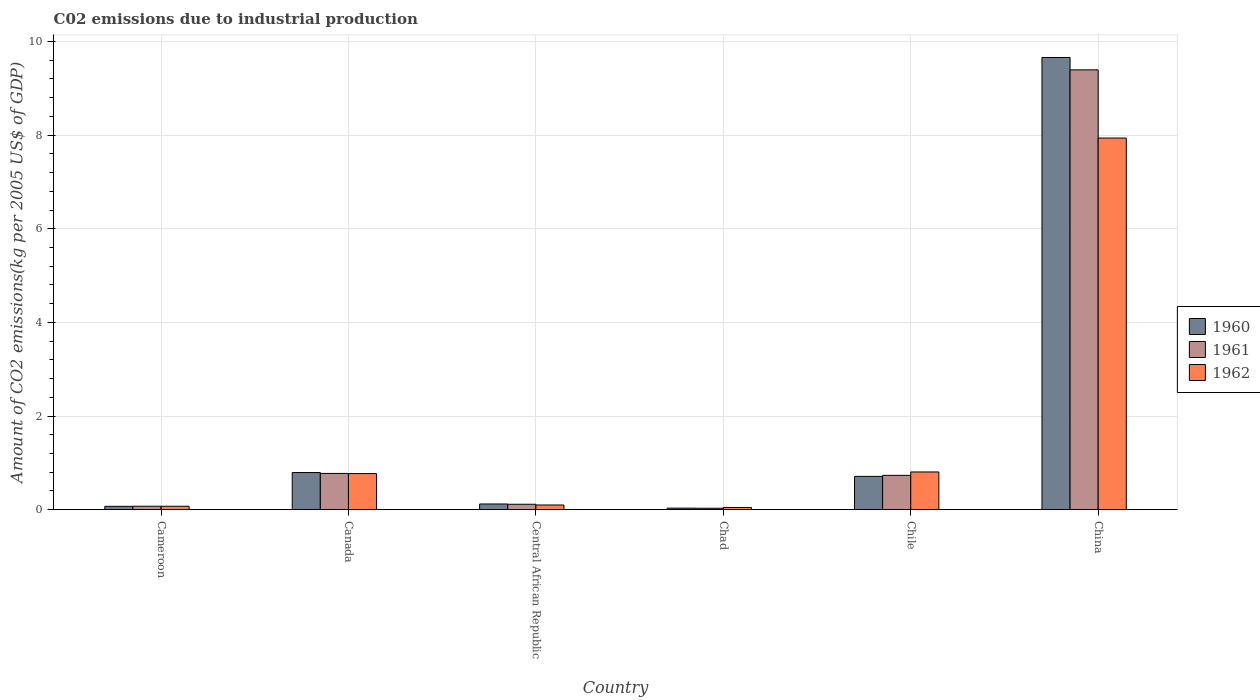How many bars are there on the 1st tick from the left?
Keep it short and to the point. 3. What is the label of the 4th group of bars from the left?
Give a very brief answer. Chad. In how many cases, is the number of bars for a given country not equal to the number of legend labels?
Ensure brevity in your answer.  0. What is the amount of CO2 emitted due to industrial production in 1960 in Canada?
Provide a short and direct response. 0.79. Across all countries, what is the maximum amount of CO2 emitted due to industrial production in 1962?
Make the answer very short. 7.94. Across all countries, what is the minimum amount of CO2 emitted due to industrial production in 1962?
Keep it short and to the point. 0.05. In which country was the amount of CO2 emitted due to industrial production in 1961 maximum?
Offer a terse response. China. In which country was the amount of CO2 emitted due to industrial production in 1961 minimum?
Offer a terse response. Chad. What is the total amount of CO2 emitted due to industrial production in 1961 in the graph?
Your answer should be compact. 11.12. What is the difference between the amount of CO2 emitted due to industrial production in 1960 in Central African Republic and that in Chad?
Ensure brevity in your answer.  0.09. What is the difference between the amount of CO2 emitted due to industrial production in 1960 in Canada and the amount of CO2 emitted due to industrial production in 1961 in Central African Republic?
Keep it short and to the point. 0.68. What is the average amount of CO2 emitted due to industrial production in 1962 per country?
Offer a very short reply. 1.62. What is the difference between the amount of CO2 emitted due to industrial production of/in 1960 and amount of CO2 emitted due to industrial production of/in 1961 in Cameroon?
Make the answer very short. -0. What is the ratio of the amount of CO2 emitted due to industrial production in 1961 in Canada to that in China?
Offer a very short reply. 0.08. What is the difference between the highest and the second highest amount of CO2 emitted due to industrial production in 1961?
Provide a succinct answer. -8.62. What is the difference between the highest and the lowest amount of CO2 emitted due to industrial production in 1960?
Provide a short and direct response. 9.62. In how many countries, is the amount of CO2 emitted due to industrial production in 1961 greater than the average amount of CO2 emitted due to industrial production in 1961 taken over all countries?
Give a very brief answer. 1. What does the 2nd bar from the left in Central African Republic represents?
Your answer should be very brief. 1961. What does the 2nd bar from the right in Cameroon represents?
Your answer should be compact. 1961. Are all the bars in the graph horizontal?
Give a very brief answer. No. How many countries are there in the graph?
Provide a succinct answer. 6. What is the difference between two consecutive major ticks on the Y-axis?
Ensure brevity in your answer.  2. Where does the legend appear in the graph?
Your response must be concise. Center right. What is the title of the graph?
Provide a short and direct response. C02 emissions due to industrial production. Does "1973" appear as one of the legend labels in the graph?
Offer a terse response. No. What is the label or title of the Y-axis?
Ensure brevity in your answer.  Amount of CO2 emissions(kg per 2005 US$ of GDP). What is the Amount of CO2 emissions(kg per 2005 US$ of GDP) of 1960 in Cameroon?
Offer a very short reply. 0.07. What is the Amount of CO2 emissions(kg per 2005 US$ of GDP) in 1961 in Cameroon?
Provide a short and direct response. 0.07. What is the Amount of CO2 emissions(kg per 2005 US$ of GDP) of 1962 in Cameroon?
Your answer should be very brief. 0.07. What is the Amount of CO2 emissions(kg per 2005 US$ of GDP) of 1960 in Canada?
Your response must be concise. 0.79. What is the Amount of CO2 emissions(kg per 2005 US$ of GDP) in 1961 in Canada?
Make the answer very short. 0.77. What is the Amount of CO2 emissions(kg per 2005 US$ of GDP) in 1962 in Canada?
Ensure brevity in your answer.  0.77. What is the Amount of CO2 emissions(kg per 2005 US$ of GDP) in 1960 in Central African Republic?
Make the answer very short. 0.12. What is the Amount of CO2 emissions(kg per 2005 US$ of GDP) in 1961 in Central African Republic?
Keep it short and to the point. 0.12. What is the Amount of CO2 emissions(kg per 2005 US$ of GDP) in 1962 in Central African Republic?
Provide a short and direct response. 0.1. What is the Amount of CO2 emissions(kg per 2005 US$ of GDP) in 1960 in Chad?
Offer a terse response. 0.03. What is the Amount of CO2 emissions(kg per 2005 US$ of GDP) of 1961 in Chad?
Make the answer very short. 0.03. What is the Amount of CO2 emissions(kg per 2005 US$ of GDP) of 1962 in Chad?
Give a very brief answer. 0.05. What is the Amount of CO2 emissions(kg per 2005 US$ of GDP) of 1960 in Chile?
Provide a succinct answer. 0.71. What is the Amount of CO2 emissions(kg per 2005 US$ of GDP) in 1961 in Chile?
Offer a very short reply. 0.73. What is the Amount of CO2 emissions(kg per 2005 US$ of GDP) in 1962 in Chile?
Ensure brevity in your answer.  0.81. What is the Amount of CO2 emissions(kg per 2005 US$ of GDP) in 1960 in China?
Your answer should be very brief. 9.66. What is the Amount of CO2 emissions(kg per 2005 US$ of GDP) in 1961 in China?
Your answer should be very brief. 9.39. What is the Amount of CO2 emissions(kg per 2005 US$ of GDP) in 1962 in China?
Keep it short and to the point. 7.94. Across all countries, what is the maximum Amount of CO2 emissions(kg per 2005 US$ of GDP) in 1960?
Offer a very short reply. 9.66. Across all countries, what is the maximum Amount of CO2 emissions(kg per 2005 US$ of GDP) of 1961?
Ensure brevity in your answer.  9.39. Across all countries, what is the maximum Amount of CO2 emissions(kg per 2005 US$ of GDP) in 1962?
Your answer should be compact. 7.94. Across all countries, what is the minimum Amount of CO2 emissions(kg per 2005 US$ of GDP) in 1960?
Offer a terse response. 0.03. Across all countries, what is the minimum Amount of CO2 emissions(kg per 2005 US$ of GDP) of 1961?
Provide a short and direct response. 0.03. Across all countries, what is the minimum Amount of CO2 emissions(kg per 2005 US$ of GDP) of 1962?
Offer a very short reply. 0.05. What is the total Amount of CO2 emissions(kg per 2005 US$ of GDP) in 1960 in the graph?
Your answer should be very brief. 11.39. What is the total Amount of CO2 emissions(kg per 2005 US$ of GDP) in 1961 in the graph?
Make the answer very short. 11.12. What is the total Amount of CO2 emissions(kg per 2005 US$ of GDP) in 1962 in the graph?
Offer a very short reply. 9.74. What is the difference between the Amount of CO2 emissions(kg per 2005 US$ of GDP) in 1960 in Cameroon and that in Canada?
Keep it short and to the point. -0.72. What is the difference between the Amount of CO2 emissions(kg per 2005 US$ of GDP) of 1961 in Cameroon and that in Canada?
Provide a succinct answer. -0.7. What is the difference between the Amount of CO2 emissions(kg per 2005 US$ of GDP) in 1962 in Cameroon and that in Canada?
Offer a very short reply. -0.7. What is the difference between the Amount of CO2 emissions(kg per 2005 US$ of GDP) of 1960 in Cameroon and that in Central African Republic?
Your answer should be very brief. -0.05. What is the difference between the Amount of CO2 emissions(kg per 2005 US$ of GDP) in 1961 in Cameroon and that in Central African Republic?
Keep it short and to the point. -0.04. What is the difference between the Amount of CO2 emissions(kg per 2005 US$ of GDP) of 1962 in Cameroon and that in Central African Republic?
Keep it short and to the point. -0.03. What is the difference between the Amount of CO2 emissions(kg per 2005 US$ of GDP) in 1960 in Cameroon and that in Chad?
Ensure brevity in your answer.  0.04. What is the difference between the Amount of CO2 emissions(kg per 2005 US$ of GDP) in 1961 in Cameroon and that in Chad?
Keep it short and to the point. 0.04. What is the difference between the Amount of CO2 emissions(kg per 2005 US$ of GDP) of 1962 in Cameroon and that in Chad?
Your answer should be compact. 0.03. What is the difference between the Amount of CO2 emissions(kg per 2005 US$ of GDP) of 1960 in Cameroon and that in Chile?
Make the answer very short. -0.64. What is the difference between the Amount of CO2 emissions(kg per 2005 US$ of GDP) of 1961 in Cameroon and that in Chile?
Offer a very short reply. -0.66. What is the difference between the Amount of CO2 emissions(kg per 2005 US$ of GDP) in 1962 in Cameroon and that in Chile?
Your response must be concise. -0.73. What is the difference between the Amount of CO2 emissions(kg per 2005 US$ of GDP) in 1960 in Cameroon and that in China?
Your answer should be very brief. -9.59. What is the difference between the Amount of CO2 emissions(kg per 2005 US$ of GDP) in 1961 in Cameroon and that in China?
Your response must be concise. -9.32. What is the difference between the Amount of CO2 emissions(kg per 2005 US$ of GDP) in 1962 in Cameroon and that in China?
Give a very brief answer. -7.86. What is the difference between the Amount of CO2 emissions(kg per 2005 US$ of GDP) of 1960 in Canada and that in Central African Republic?
Provide a succinct answer. 0.67. What is the difference between the Amount of CO2 emissions(kg per 2005 US$ of GDP) in 1961 in Canada and that in Central African Republic?
Your answer should be very brief. 0.66. What is the difference between the Amount of CO2 emissions(kg per 2005 US$ of GDP) of 1962 in Canada and that in Central African Republic?
Keep it short and to the point. 0.67. What is the difference between the Amount of CO2 emissions(kg per 2005 US$ of GDP) in 1960 in Canada and that in Chad?
Offer a terse response. 0.76. What is the difference between the Amount of CO2 emissions(kg per 2005 US$ of GDP) of 1961 in Canada and that in Chad?
Your answer should be compact. 0.74. What is the difference between the Amount of CO2 emissions(kg per 2005 US$ of GDP) in 1962 in Canada and that in Chad?
Ensure brevity in your answer.  0.72. What is the difference between the Amount of CO2 emissions(kg per 2005 US$ of GDP) in 1960 in Canada and that in Chile?
Keep it short and to the point. 0.08. What is the difference between the Amount of CO2 emissions(kg per 2005 US$ of GDP) of 1961 in Canada and that in Chile?
Your response must be concise. 0.04. What is the difference between the Amount of CO2 emissions(kg per 2005 US$ of GDP) in 1962 in Canada and that in Chile?
Provide a short and direct response. -0.03. What is the difference between the Amount of CO2 emissions(kg per 2005 US$ of GDP) of 1960 in Canada and that in China?
Ensure brevity in your answer.  -8.86. What is the difference between the Amount of CO2 emissions(kg per 2005 US$ of GDP) in 1961 in Canada and that in China?
Provide a succinct answer. -8.62. What is the difference between the Amount of CO2 emissions(kg per 2005 US$ of GDP) of 1962 in Canada and that in China?
Provide a short and direct response. -7.17. What is the difference between the Amount of CO2 emissions(kg per 2005 US$ of GDP) in 1960 in Central African Republic and that in Chad?
Make the answer very short. 0.09. What is the difference between the Amount of CO2 emissions(kg per 2005 US$ of GDP) of 1961 in Central African Republic and that in Chad?
Make the answer very short. 0.09. What is the difference between the Amount of CO2 emissions(kg per 2005 US$ of GDP) of 1962 in Central African Republic and that in Chad?
Offer a terse response. 0.05. What is the difference between the Amount of CO2 emissions(kg per 2005 US$ of GDP) in 1960 in Central African Republic and that in Chile?
Provide a short and direct response. -0.59. What is the difference between the Amount of CO2 emissions(kg per 2005 US$ of GDP) of 1961 in Central African Republic and that in Chile?
Your answer should be very brief. -0.62. What is the difference between the Amount of CO2 emissions(kg per 2005 US$ of GDP) in 1962 in Central African Republic and that in Chile?
Offer a very short reply. -0.71. What is the difference between the Amount of CO2 emissions(kg per 2005 US$ of GDP) of 1960 in Central African Republic and that in China?
Offer a terse response. -9.54. What is the difference between the Amount of CO2 emissions(kg per 2005 US$ of GDP) of 1961 in Central African Republic and that in China?
Ensure brevity in your answer.  -9.28. What is the difference between the Amount of CO2 emissions(kg per 2005 US$ of GDP) in 1962 in Central African Republic and that in China?
Provide a succinct answer. -7.84. What is the difference between the Amount of CO2 emissions(kg per 2005 US$ of GDP) of 1960 in Chad and that in Chile?
Make the answer very short. -0.68. What is the difference between the Amount of CO2 emissions(kg per 2005 US$ of GDP) of 1961 in Chad and that in Chile?
Your answer should be compact. -0.7. What is the difference between the Amount of CO2 emissions(kg per 2005 US$ of GDP) in 1962 in Chad and that in Chile?
Provide a succinct answer. -0.76. What is the difference between the Amount of CO2 emissions(kg per 2005 US$ of GDP) of 1960 in Chad and that in China?
Your response must be concise. -9.62. What is the difference between the Amount of CO2 emissions(kg per 2005 US$ of GDP) in 1961 in Chad and that in China?
Your answer should be very brief. -9.36. What is the difference between the Amount of CO2 emissions(kg per 2005 US$ of GDP) of 1962 in Chad and that in China?
Provide a short and direct response. -7.89. What is the difference between the Amount of CO2 emissions(kg per 2005 US$ of GDP) in 1960 in Chile and that in China?
Provide a short and direct response. -8.95. What is the difference between the Amount of CO2 emissions(kg per 2005 US$ of GDP) of 1961 in Chile and that in China?
Your answer should be very brief. -8.66. What is the difference between the Amount of CO2 emissions(kg per 2005 US$ of GDP) in 1962 in Chile and that in China?
Provide a succinct answer. -7.13. What is the difference between the Amount of CO2 emissions(kg per 2005 US$ of GDP) of 1960 in Cameroon and the Amount of CO2 emissions(kg per 2005 US$ of GDP) of 1961 in Canada?
Give a very brief answer. -0.7. What is the difference between the Amount of CO2 emissions(kg per 2005 US$ of GDP) of 1960 in Cameroon and the Amount of CO2 emissions(kg per 2005 US$ of GDP) of 1962 in Canada?
Provide a short and direct response. -0.7. What is the difference between the Amount of CO2 emissions(kg per 2005 US$ of GDP) of 1961 in Cameroon and the Amount of CO2 emissions(kg per 2005 US$ of GDP) of 1962 in Canada?
Provide a short and direct response. -0.7. What is the difference between the Amount of CO2 emissions(kg per 2005 US$ of GDP) of 1960 in Cameroon and the Amount of CO2 emissions(kg per 2005 US$ of GDP) of 1961 in Central African Republic?
Make the answer very short. -0.04. What is the difference between the Amount of CO2 emissions(kg per 2005 US$ of GDP) of 1960 in Cameroon and the Amount of CO2 emissions(kg per 2005 US$ of GDP) of 1962 in Central African Republic?
Your answer should be compact. -0.03. What is the difference between the Amount of CO2 emissions(kg per 2005 US$ of GDP) of 1961 in Cameroon and the Amount of CO2 emissions(kg per 2005 US$ of GDP) of 1962 in Central African Republic?
Make the answer very short. -0.03. What is the difference between the Amount of CO2 emissions(kg per 2005 US$ of GDP) of 1960 in Cameroon and the Amount of CO2 emissions(kg per 2005 US$ of GDP) of 1961 in Chad?
Keep it short and to the point. 0.04. What is the difference between the Amount of CO2 emissions(kg per 2005 US$ of GDP) in 1960 in Cameroon and the Amount of CO2 emissions(kg per 2005 US$ of GDP) in 1962 in Chad?
Keep it short and to the point. 0.02. What is the difference between the Amount of CO2 emissions(kg per 2005 US$ of GDP) of 1961 in Cameroon and the Amount of CO2 emissions(kg per 2005 US$ of GDP) of 1962 in Chad?
Your answer should be compact. 0.03. What is the difference between the Amount of CO2 emissions(kg per 2005 US$ of GDP) in 1960 in Cameroon and the Amount of CO2 emissions(kg per 2005 US$ of GDP) in 1961 in Chile?
Provide a succinct answer. -0.66. What is the difference between the Amount of CO2 emissions(kg per 2005 US$ of GDP) of 1960 in Cameroon and the Amount of CO2 emissions(kg per 2005 US$ of GDP) of 1962 in Chile?
Your answer should be very brief. -0.73. What is the difference between the Amount of CO2 emissions(kg per 2005 US$ of GDP) in 1961 in Cameroon and the Amount of CO2 emissions(kg per 2005 US$ of GDP) in 1962 in Chile?
Your answer should be compact. -0.73. What is the difference between the Amount of CO2 emissions(kg per 2005 US$ of GDP) of 1960 in Cameroon and the Amount of CO2 emissions(kg per 2005 US$ of GDP) of 1961 in China?
Your response must be concise. -9.32. What is the difference between the Amount of CO2 emissions(kg per 2005 US$ of GDP) in 1960 in Cameroon and the Amount of CO2 emissions(kg per 2005 US$ of GDP) in 1962 in China?
Your answer should be compact. -7.87. What is the difference between the Amount of CO2 emissions(kg per 2005 US$ of GDP) of 1961 in Cameroon and the Amount of CO2 emissions(kg per 2005 US$ of GDP) of 1962 in China?
Provide a succinct answer. -7.86. What is the difference between the Amount of CO2 emissions(kg per 2005 US$ of GDP) in 1960 in Canada and the Amount of CO2 emissions(kg per 2005 US$ of GDP) in 1961 in Central African Republic?
Offer a terse response. 0.68. What is the difference between the Amount of CO2 emissions(kg per 2005 US$ of GDP) of 1960 in Canada and the Amount of CO2 emissions(kg per 2005 US$ of GDP) of 1962 in Central African Republic?
Your answer should be very brief. 0.69. What is the difference between the Amount of CO2 emissions(kg per 2005 US$ of GDP) of 1961 in Canada and the Amount of CO2 emissions(kg per 2005 US$ of GDP) of 1962 in Central African Republic?
Provide a short and direct response. 0.67. What is the difference between the Amount of CO2 emissions(kg per 2005 US$ of GDP) in 1960 in Canada and the Amount of CO2 emissions(kg per 2005 US$ of GDP) in 1961 in Chad?
Your answer should be compact. 0.76. What is the difference between the Amount of CO2 emissions(kg per 2005 US$ of GDP) in 1960 in Canada and the Amount of CO2 emissions(kg per 2005 US$ of GDP) in 1962 in Chad?
Your answer should be very brief. 0.75. What is the difference between the Amount of CO2 emissions(kg per 2005 US$ of GDP) of 1961 in Canada and the Amount of CO2 emissions(kg per 2005 US$ of GDP) of 1962 in Chad?
Your response must be concise. 0.73. What is the difference between the Amount of CO2 emissions(kg per 2005 US$ of GDP) in 1960 in Canada and the Amount of CO2 emissions(kg per 2005 US$ of GDP) in 1961 in Chile?
Your answer should be compact. 0.06. What is the difference between the Amount of CO2 emissions(kg per 2005 US$ of GDP) in 1960 in Canada and the Amount of CO2 emissions(kg per 2005 US$ of GDP) in 1962 in Chile?
Your answer should be very brief. -0.01. What is the difference between the Amount of CO2 emissions(kg per 2005 US$ of GDP) of 1961 in Canada and the Amount of CO2 emissions(kg per 2005 US$ of GDP) of 1962 in Chile?
Offer a terse response. -0.03. What is the difference between the Amount of CO2 emissions(kg per 2005 US$ of GDP) of 1960 in Canada and the Amount of CO2 emissions(kg per 2005 US$ of GDP) of 1961 in China?
Keep it short and to the point. -8.6. What is the difference between the Amount of CO2 emissions(kg per 2005 US$ of GDP) in 1960 in Canada and the Amount of CO2 emissions(kg per 2005 US$ of GDP) in 1962 in China?
Provide a succinct answer. -7.14. What is the difference between the Amount of CO2 emissions(kg per 2005 US$ of GDP) of 1961 in Canada and the Amount of CO2 emissions(kg per 2005 US$ of GDP) of 1962 in China?
Your answer should be very brief. -7.16. What is the difference between the Amount of CO2 emissions(kg per 2005 US$ of GDP) in 1960 in Central African Republic and the Amount of CO2 emissions(kg per 2005 US$ of GDP) in 1961 in Chad?
Ensure brevity in your answer.  0.09. What is the difference between the Amount of CO2 emissions(kg per 2005 US$ of GDP) of 1960 in Central African Republic and the Amount of CO2 emissions(kg per 2005 US$ of GDP) of 1962 in Chad?
Your answer should be very brief. 0.07. What is the difference between the Amount of CO2 emissions(kg per 2005 US$ of GDP) of 1961 in Central African Republic and the Amount of CO2 emissions(kg per 2005 US$ of GDP) of 1962 in Chad?
Offer a very short reply. 0.07. What is the difference between the Amount of CO2 emissions(kg per 2005 US$ of GDP) in 1960 in Central African Republic and the Amount of CO2 emissions(kg per 2005 US$ of GDP) in 1961 in Chile?
Ensure brevity in your answer.  -0.61. What is the difference between the Amount of CO2 emissions(kg per 2005 US$ of GDP) in 1960 in Central African Republic and the Amount of CO2 emissions(kg per 2005 US$ of GDP) in 1962 in Chile?
Offer a terse response. -0.68. What is the difference between the Amount of CO2 emissions(kg per 2005 US$ of GDP) of 1961 in Central African Republic and the Amount of CO2 emissions(kg per 2005 US$ of GDP) of 1962 in Chile?
Make the answer very short. -0.69. What is the difference between the Amount of CO2 emissions(kg per 2005 US$ of GDP) in 1960 in Central African Republic and the Amount of CO2 emissions(kg per 2005 US$ of GDP) in 1961 in China?
Offer a very short reply. -9.27. What is the difference between the Amount of CO2 emissions(kg per 2005 US$ of GDP) in 1960 in Central African Republic and the Amount of CO2 emissions(kg per 2005 US$ of GDP) in 1962 in China?
Give a very brief answer. -7.82. What is the difference between the Amount of CO2 emissions(kg per 2005 US$ of GDP) in 1961 in Central African Republic and the Amount of CO2 emissions(kg per 2005 US$ of GDP) in 1962 in China?
Provide a succinct answer. -7.82. What is the difference between the Amount of CO2 emissions(kg per 2005 US$ of GDP) in 1960 in Chad and the Amount of CO2 emissions(kg per 2005 US$ of GDP) in 1961 in Chile?
Ensure brevity in your answer.  -0.7. What is the difference between the Amount of CO2 emissions(kg per 2005 US$ of GDP) of 1960 in Chad and the Amount of CO2 emissions(kg per 2005 US$ of GDP) of 1962 in Chile?
Keep it short and to the point. -0.77. What is the difference between the Amount of CO2 emissions(kg per 2005 US$ of GDP) in 1961 in Chad and the Amount of CO2 emissions(kg per 2005 US$ of GDP) in 1962 in Chile?
Provide a short and direct response. -0.78. What is the difference between the Amount of CO2 emissions(kg per 2005 US$ of GDP) in 1960 in Chad and the Amount of CO2 emissions(kg per 2005 US$ of GDP) in 1961 in China?
Provide a succinct answer. -9.36. What is the difference between the Amount of CO2 emissions(kg per 2005 US$ of GDP) in 1960 in Chad and the Amount of CO2 emissions(kg per 2005 US$ of GDP) in 1962 in China?
Provide a succinct answer. -7.9. What is the difference between the Amount of CO2 emissions(kg per 2005 US$ of GDP) of 1961 in Chad and the Amount of CO2 emissions(kg per 2005 US$ of GDP) of 1962 in China?
Your response must be concise. -7.91. What is the difference between the Amount of CO2 emissions(kg per 2005 US$ of GDP) in 1960 in Chile and the Amount of CO2 emissions(kg per 2005 US$ of GDP) in 1961 in China?
Provide a succinct answer. -8.68. What is the difference between the Amount of CO2 emissions(kg per 2005 US$ of GDP) in 1960 in Chile and the Amount of CO2 emissions(kg per 2005 US$ of GDP) in 1962 in China?
Offer a terse response. -7.23. What is the difference between the Amount of CO2 emissions(kg per 2005 US$ of GDP) in 1961 in Chile and the Amount of CO2 emissions(kg per 2005 US$ of GDP) in 1962 in China?
Ensure brevity in your answer.  -7.2. What is the average Amount of CO2 emissions(kg per 2005 US$ of GDP) in 1960 per country?
Your response must be concise. 1.9. What is the average Amount of CO2 emissions(kg per 2005 US$ of GDP) of 1961 per country?
Keep it short and to the point. 1.85. What is the average Amount of CO2 emissions(kg per 2005 US$ of GDP) in 1962 per country?
Your response must be concise. 1.62. What is the difference between the Amount of CO2 emissions(kg per 2005 US$ of GDP) in 1960 and Amount of CO2 emissions(kg per 2005 US$ of GDP) in 1961 in Cameroon?
Your response must be concise. -0. What is the difference between the Amount of CO2 emissions(kg per 2005 US$ of GDP) in 1960 and Amount of CO2 emissions(kg per 2005 US$ of GDP) in 1962 in Cameroon?
Offer a terse response. -0. What is the difference between the Amount of CO2 emissions(kg per 2005 US$ of GDP) of 1960 and Amount of CO2 emissions(kg per 2005 US$ of GDP) of 1961 in Canada?
Give a very brief answer. 0.02. What is the difference between the Amount of CO2 emissions(kg per 2005 US$ of GDP) of 1960 and Amount of CO2 emissions(kg per 2005 US$ of GDP) of 1962 in Canada?
Your answer should be compact. 0.02. What is the difference between the Amount of CO2 emissions(kg per 2005 US$ of GDP) in 1961 and Amount of CO2 emissions(kg per 2005 US$ of GDP) in 1962 in Canada?
Make the answer very short. 0. What is the difference between the Amount of CO2 emissions(kg per 2005 US$ of GDP) in 1960 and Amount of CO2 emissions(kg per 2005 US$ of GDP) in 1961 in Central African Republic?
Give a very brief answer. 0.01. What is the difference between the Amount of CO2 emissions(kg per 2005 US$ of GDP) in 1960 and Amount of CO2 emissions(kg per 2005 US$ of GDP) in 1962 in Central African Republic?
Give a very brief answer. 0.02. What is the difference between the Amount of CO2 emissions(kg per 2005 US$ of GDP) of 1961 and Amount of CO2 emissions(kg per 2005 US$ of GDP) of 1962 in Central African Republic?
Make the answer very short. 0.02. What is the difference between the Amount of CO2 emissions(kg per 2005 US$ of GDP) of 1960 and Amount of CO2 emissions(kg per 2005 US$ of GDP) of 1961 in Chad?
Provide a succinct answer. 0. What is the difference between the Amount of CO2 emissions(kg per 2005 US$ of GDP) in 1960 and Amount of CO2 emissions(kg per 2005 US$ of GDP) in 1962 in Chad?
Offer a terse response. -0.01. What is the difference between the Amount of CO2 emissions(kg per 2005 US$ of GDP) in 1961 and Amount of CO2 emissions(kg per 2005 US$ of GDP) in 1962 in Chad?
Your answer should be very brief. -0.02. What is the difference between the Amount of CO2 emissions(kg per 2005 US$ of GDP) in 1960 and Amount of CO2 emissions(kg per 2005 US$ of GDP) in 1961 in Chile?
Your answer should be very brief. -0.02. What is the difference between the Amount of CO2 emissions(kg per 2005 US$ of GDP) in 1960 and Amount of CO2 emissions(kg per 2005 US$ of GDP) in 1962 in Chile?
Give a very brief answer. -0.09. What is the difference between the Amount of CO2 emissions(kg per 2005 US$ of GDP) in 1961 and Amount of CO2 emissions(kg per 2005 US$ of GDP) in 1962 in Chile?
Make the answer very short. -0.07. What is the difference between the Amount of CO2 emissions(kg per 2005 US$ of GDP) of 1960 and Amount of CO2 emissions(kg per 2005 US$ of GDP) of 1961 in China?
Your response must be concise. 0.26. What is the difference between the Amount of CO2 emissions(kg per 2005 US$ of GDP) in 1960 and Amount of CO2 emissions(kg per 2005 US$ of GDP) in 1962 in China?
Ensure brevity in your answer.  1.72. What is the difference between the Amount of CO2 emissions(kg per 2005 US$ of GDP) of 1961 and Amount of CO2 emissions(kg per 2005 US$ of GDP) of 1962 in China?
Provide a succinct answer. 1.46. What is the ratio of the Amount of CO2 emissions(kg per 2005 US$ of GDP) of 1960 in Cameroon to that in Canada?
Give a very brief answer. 0.09. What is the ratio of the Amount of CO2 emissions(kg per 2005 US$ of GDP) in 1961 in Cameroon to that in Canada?
Ensure brevity in your answer.  0.1. What is the ratio of the Amount of CO2 emissions(kg per 2005 US$ of GDP) of 1962 in Cameroon to that in Canada?
Make the answer very short. 0.1. What is the ratio of the Amount of CO2 emissions(kg per 2005 US$ of GDP) in 1960 in Cameroon to that in Central African Republic?
Make the answer very short. 0.59. What is the ratio of the Amount of CO2 emissions(kg per 2005 US$ of GDP) of 1961 in Cameroon to that in Central African Republic?
Offer a very short reply. 0.64. What is the ratio of the Amount of CO2 emissions(kg per 2005 US$ of GDP) in 1962 in Cameroon to that in Central African Republic?
Your response must be concise. 0.73. What is the ratio of the Amount of CO2 emissions(kg per 2005 US$ of GDP) in 1960 in Cameroon to that in Chad?
Your answer should be very brief. 2.16. What is the ratio of the Amount of CO2 emissions(kg per 2005 US$ of GDP) in 1961 in Cameroon to that in Chad?
Your response must be concise. 2.41. What is the ratio of the Amount of CO2 emissions(kg per 2005 US$ of GDP) of 1962 in Cameroon to that in Chad?
Your answer should be very brief. 1.54. What is the ratio of the Amount of CO2 emissions(kg per 2005 US$ of GDP) of 1960 in Cameroon to that in Chile?
Your answer should be compact. 0.1. What is the ratio of the Amount of CO2 emissions(kg per 2005 US$ of GDP) in 1961 in Cameroon to that in Chile?
Ensure brevity in your answer.  0.1. What is the ratio of the Amount of CO2 emissions(kg per 2005 US$ of GDP) in 1962 in Cameroon to that in Chile?
Your response must be concise. 0.09. What is the ratio of the Amount of CO2 emissions(kg per 2005 US$ of GDP) in 1960 in Cameroon to that in China?
Keep it short and to the point. 0.01. What is the ratio of the Amount of CO2 emissions(kg per 2005 US$ of GDP) of 1961 in Cameroon to that in China?
Your response must be concise. 0.01. What is the ratio of the Amount of CO2 emissions(kg per 2005 US$ of GDP) of 1962 in Cameroon to that in China?
Ensure brevity in your answer.  0.01. What is the ratio of the Amount of CO2 emissions(kg per 2005 US$ of GDP) in 1960 in Canada to that in Central African Republic?
Give a very brief answer. 6.5. What is the ratio of the Amount of CO2 emissions(kg per 2005 US$ of GDP) in 1961 in Canada to that in Central African Republic?
Your answer should be very brief. 6.66. What is the ratio of the Amount of CO2 emissions(kg per 2005 US$ of GDP) of 1962 in Canada to that in Central African Republic?
Keep it short and to the point. 7.67. What is the ratio of the Amount of CO2 emissions(kg per 2005 US$ of GDP) in 1960 in Canada to that in Chad?
Make the answer very short. 23.84. What is the ratio of the Amount of CO2 emissions(kg per 2005 US$ of GDP) in 1961 in Canada to that in Chad?
Make the answer very short. 25.27. What is the ratio of the Amount of CO2 emissions(kg per 2005 US$ of GDP) of 1962 in Canada to that in Chad?
Give a very brief answer. 16.14. What is the ratio of the Amount of CO2 emissions(kg per 2005 US$ of GDP) in 1960 in Canada to that in Chile?
Your answer should be very brief. 1.12. What is the ratio of the Amount of CO2 emissions(kg per 2005 US$ of GDP) of 1961 in Canada to that in Chile?
Keep it short and to the point. 1.06. What is the ratio of the Amount of CO2 emissions(kg per 2005 US$ of GDP) of 1962 in Canada to that in Chile?
Your answer should be compact. 0.96. What is the ratio of the Amount of CO2 emissions(kg per 2005 US$ of GDP) in 1960 in Canada to that in China?
Keep it short and to the point. 0.08. What is the ratio of the Amount of CO2 emissions(kg per 2005 US$ of GDP) in 1961 in Canada to that in China?
Make the answer very short. 0.08. What is the ratio of the Amount of CO2 emissions(kg per 2005 US$ of GDP) in 1962 in Canada to that in China?
Your answer should be compact. 0.1. What is the ratio of the Amount of CO2 emissions(kg per 2005 US$ of GDP) in 1960 in Central African Republic to that in Chad?
Ensure brevity in your answer.  3.67. What is the ratio of the Amount of CO2 emissions(kg per 2005 US$ of GDP) in 1961 in Central African Republic to that in Chad?
Your answer should be compact. 3.79. What is the ratio of the Amount of CO2 emissions(kg per 2005 US$ of GDP) of 1962 in Central African Republic to that in Chad?
Ensure brevity in your answer.  2.11. What is the ratio of the Amount of CO2 emissions(kg per 2005 US$ of GDP) in 1960 in Central African Republic to that in Chile?
Make the answer very short. 0.17. What is the ratio of the Amount of CO2 emissions(kg per 2005 US$ of GDP) of 1961 in Central African Republic to that in Chile?
Make the answer very short. 0.16. What is the ratio of the Amount of CO2 emissions(kg per 2005 US$ of GDP) in 1962 in Central African Republic to that in Chile?
Provide a short and direct response. 0.12. What is the ratio of the Amount of CO2 emissions(kg per 2005 US$ of GDP) in 1960 in Central African Republic to that in China?
Ensure brevity in your answer.  0.01. What is the ratio of the Amount of CO2 emissions(kg per 2005 US$ of GDP) in 1961 in Central African Republic to that in China?
Your response must be concise. 0.01. What is the ratio of the Amount of CO2 emissions(kg per 2005 US$ of GDP) in 1962 in Central African Republic to that in China?
Make the answer very short. 0.01. What is the ratio of the Amount of CO2 emissions(kg per 2005 US$ of GDP) of 1960 in Chad to that in Chile?
Ensure brevity in your answer.  0.05. What is the ratio of the Amount of CO2 emissions(kg per 2005 US$ of GDP) of 1961 in Chad to that in Chile?
Make the answer very short. 0.04. What is the ratio of the Amount of CO2 emissions(kg per 2005 US$ of GDP) of 1962 in Chad to that in Chile?
Give a very brief answer. 0.06. What is the ratio of the Amount of CO2 emissions(kg per 2005 US$ of GDP) in 1960 in Chad to that in China?
Keep it short and to the point. 0. What is the ratio of the Amount of CO2 emissions(kg per 2005 US$ of GDP) in 1961 in Chad to that in China?
Provide a short and direct response. 0. What is the ratio of the Amount of CO2 emissions(kg per 2005 US$ of GDP) in 1962 in Chad to that in China?
Provide a short and direct response. 0.01. What is the ratio of the Amount of CO2 emissions(kg per 2005 US$ of GDP) in 1960 in Chile to that in China?
Your answer should be very brief. 0.07. What is the ratio of the Amount of CO2 emissions(kg per 2005 US$ of GDP) in 1961 in Chile to that in China?
Your answer should be very brief. 0.08. What is the ratio of the Amount of CO2 emissions(kg per 2005 US$ of GDP) of 1962 in Chile to that in China?
Keep it short and to the point. 0.1. What is the difference between the highest and the second highest Amount of CO2 emissions(kg per 2005 US$ of GDP) of 1960?
Ensure brevity in your answer.  8.86. What is the difference between the highest and the second highest Amount of CO2 emissions(kg per 2005 US$ of GDP) in 1961?
Your answer should be very brief. 8.62. What is the difference between the highest and the second highest Amount of CO2 emissions(kg per 2005 US$ of GDP) of 1962?
Offer a very short reply. 7.13. What is the difference between the highest and the lowest Amount of CO2 emissions(kg per 2005 US$ of GDP) in 1960?
Ensure brevity in your answer.  9.62. What is the difference between the highest and the lowest Amount of CO2 emissions(kg per 2005 US$ of GDP) in 1961?
Provide a short and direct response. 9.36. What is the difference between the highest and the lowest Amount of CO2 emissions(kg per 2005 US$ of GDP) of 1962?
Offer a terse response. 7.89. 